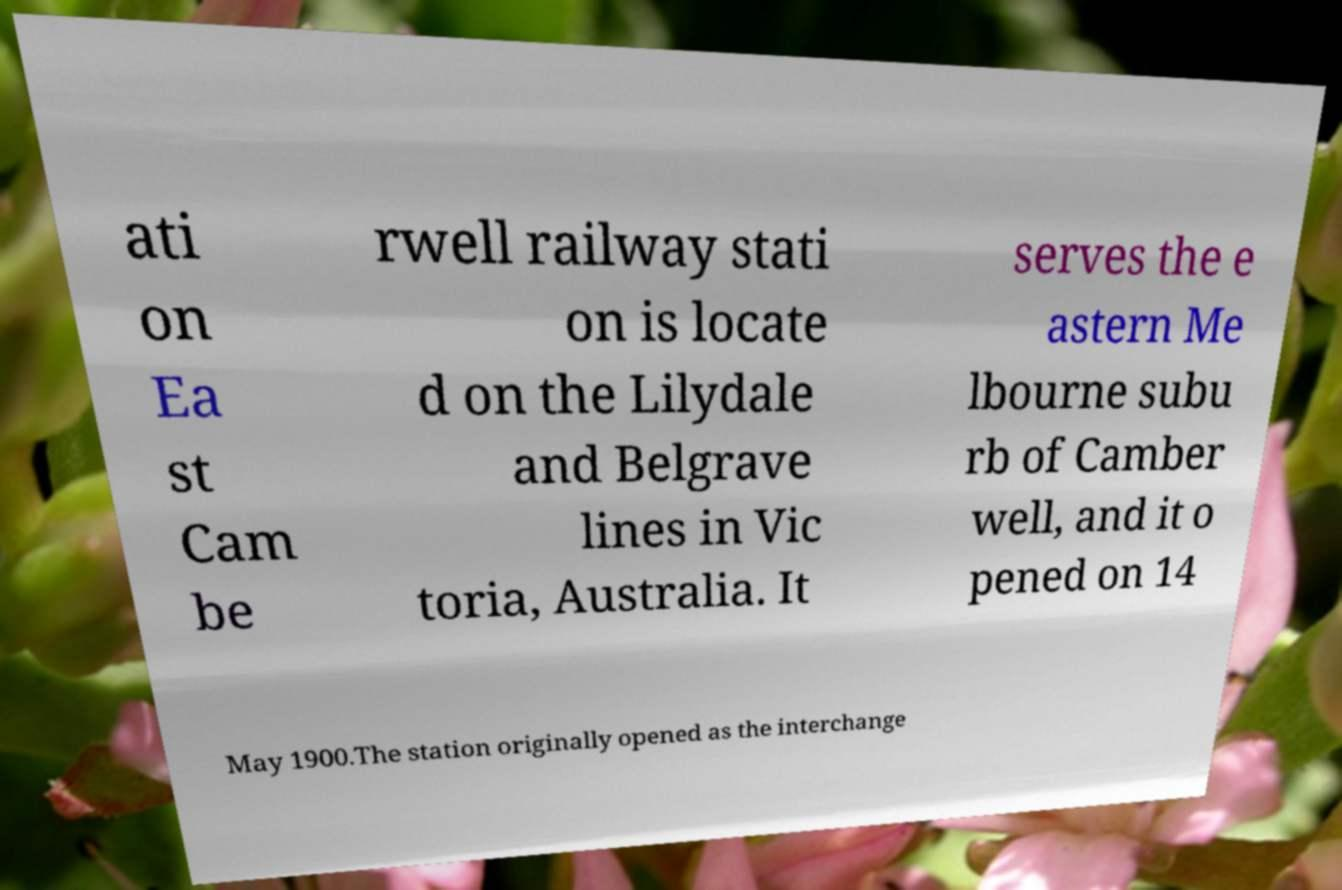Could you extract and type out the text from this image? ati on Ea st Cam be rwell railway stati on is locate d on the Lilydale and Belgrave lines in Vic toria, Australia. It serves the e astern Me lbourne subu rb of Camber well, and it o pened on 14 May 1900.The station originally opened as the interchange 